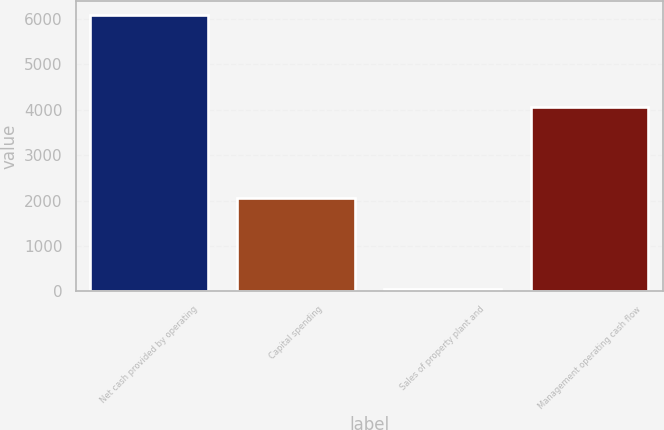Convert chart. <chart><loc_0><loc_0><loc_500><loc_500><bar_chart><fcel>Net cash provided by operating<fcel>Capital spending<fcel>Sales of property plant and<fcel>Management operating cash flow<nl><fcel>6084<fcel>2068<fcel>49<fcel>4065<nl></chart> 